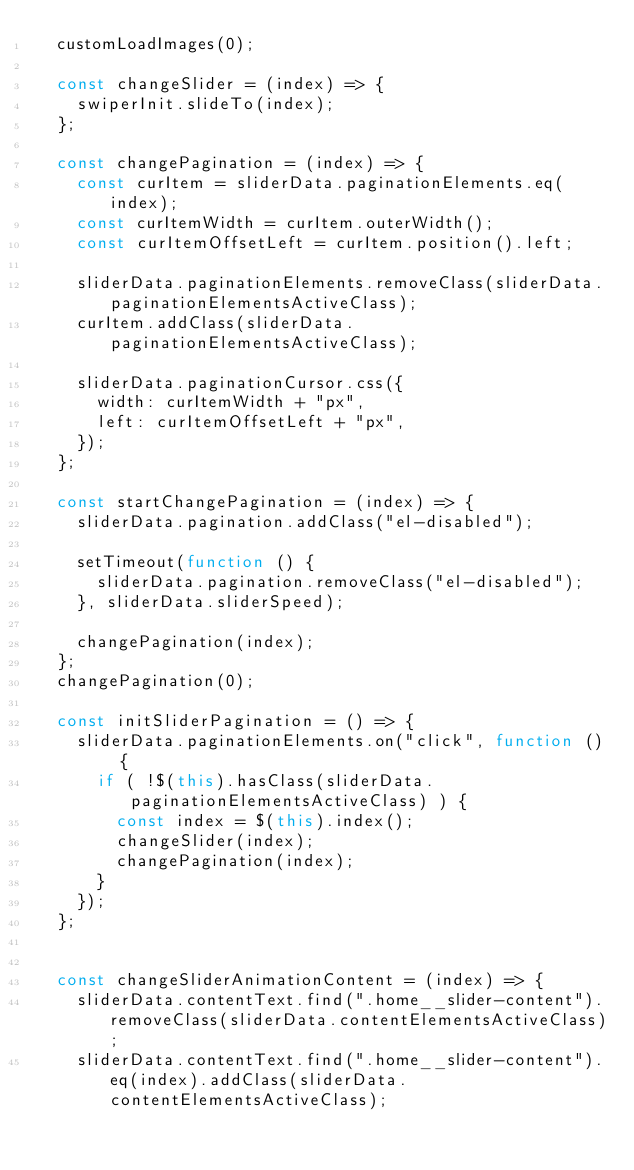<code> <loc_0><loc_0><loc_500><loc_500><_JavaScript_>	customLoadImages(0);

	const changeSlider = (index) => {
		swiperInit.slideTo(index);
	};

	const changePagination = (index) => {
		const curItem = sliderData.paginationElements.eq(index);
		const curItemWidth = curItem.outerWidth();
		const curItemOffsetLeft = curItem.position().left;

		sliderData.paginationElements.removeClass(sliderData.paginationElementsActiveClass);
		curItem.addClass(sliderData.paginationElementsActiveClass);

		sliderData.paginationCursor.css({
			width: curItemWidth + "px",
			left: curItemOffsetLeft + "px",
		});
	};

	const startChangePagination = (index) => {
		sliderData.pagination.addClass("el-disabled");

		setTimeout(function () {
			sliderData.pagination.removeClass("el-disabled");
		}, sliderData.sliderSpeed);

		changePagination(index);
	};
	changePagination(0);

	const initSliderPagination = () => {
		sliderData.paginationElements.on("click", function () {
			if ( !$(this).hasClass(sliderData.paginationElementsActiveClass) ) {
				const index = $(this).index();
				changeSlider(index);
				changePagination(index);
			}
		});
	};


	const changeSliderAnimationContent = (index) => {
		sliderData.contentText.find(".home__slider-content").removeClass(sliderData.contentElementsActiveClass);
		sliderData.contentText.find(".home__slider-content").eq(index).addClass(sliderData.contentElementsActiveClass);
</code> 